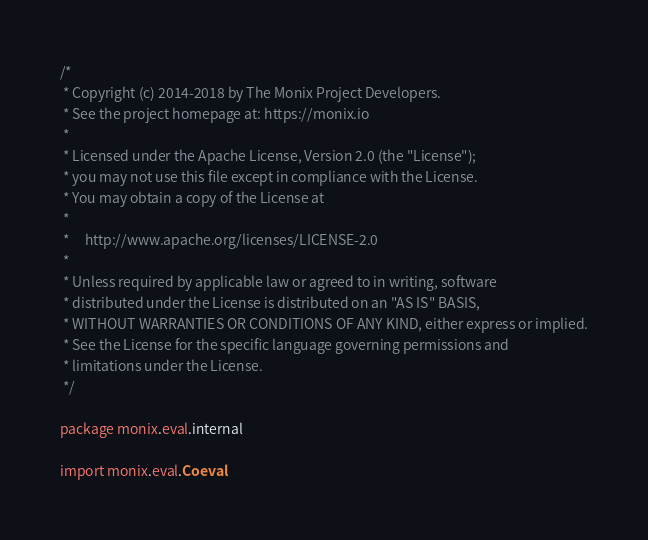<code> <loc_0><loc_0><loc_500><loc_500><_Scala_>/*
 * Copyright (c) 2014-2018 by The Monix Project Developers.
 * See the project homepage at: https://monix.io
 *
 * Licensed under the Apache License, Version 2.0 (the "License");
 * you may not use this file except in compliance with the License.
 * You may obtain a copy of the License at
 *
 *     http://www.apache.org/licenses/LICENSE-2.0
 *
 * Unless required by applicable law or agreed to in writing, software
 * distributed under the License is distributed on an "AS IS" BASIS,
 * WITHOUT WARRANTIES OR CONDITIONS OF ANY KIND, either express or implied.
 * See the License for the specific language governing permissions and
 * limitations under the License.
 */

package monix.eval.internal

import monix.eval.Coeval</code> 